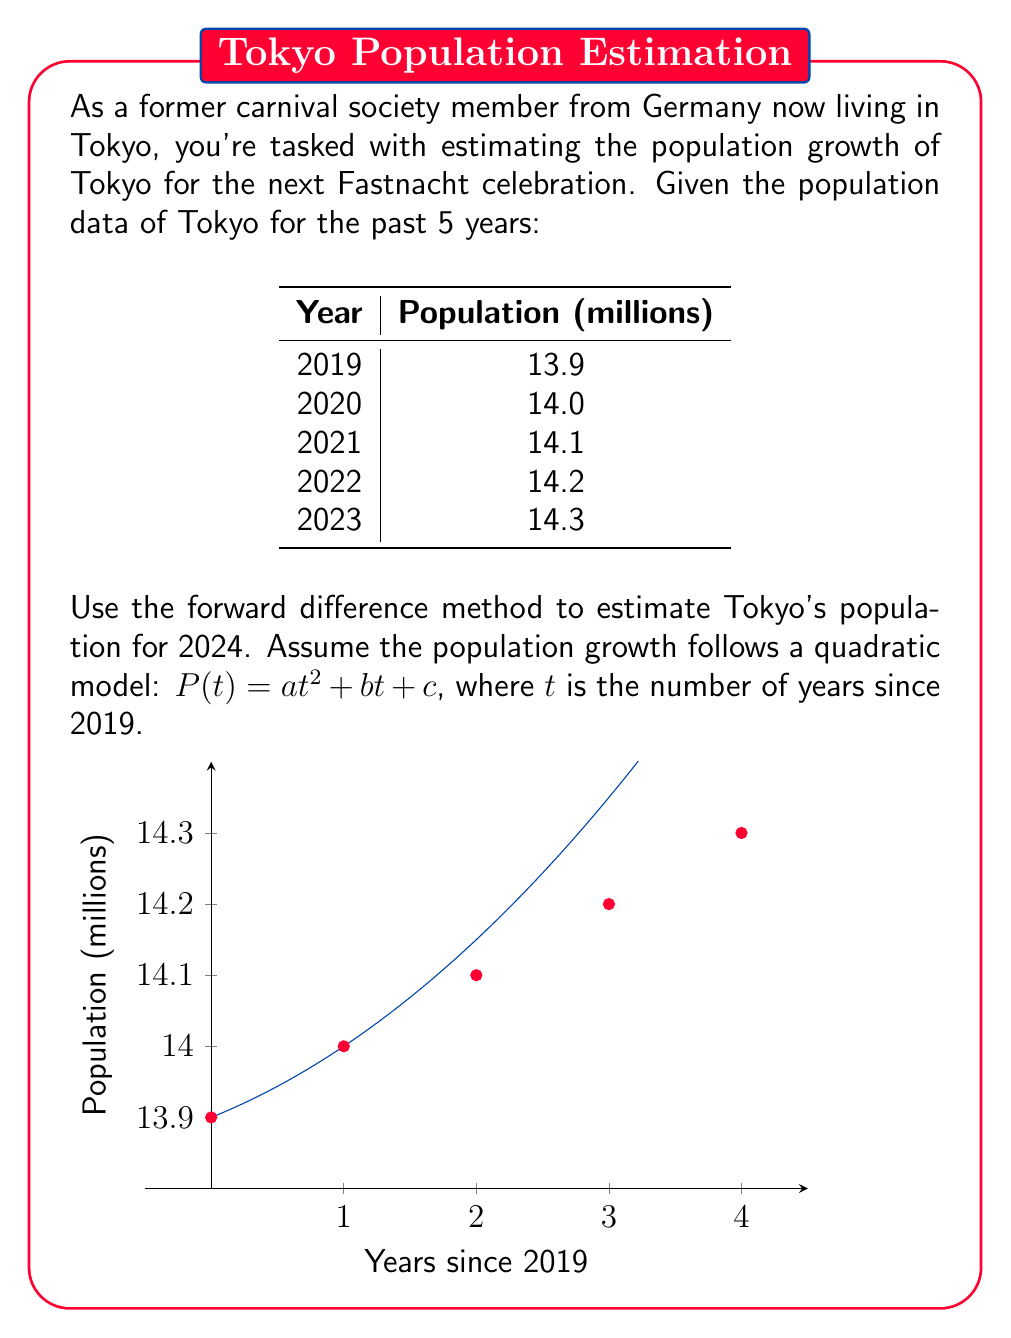Give your solution to this math problem. To solve this problem using the forward difference method, we'll follow these steps:

1) First, calculate the first-order forward differences:
   $$\Delta P_0 = P_1 - P_0 = 14.0 - 13.9 = 0.1$$
   $$\Delta P_1 = P_2 - P_1 = 14.1 - 14.0 = 0.1$$
   $$\Delta P_2 = P_3 - P_2 = 14.2 - 14.1 = 0.1$$
   $$\Delta P_3 = P_4 - P_3 = 14.3 - 14.2 = 0.1$$

2) Now, calculate the second-order forward differences:
   $$\Delta^2 P_0 = \Delta P_1 - \Delta P_0 = 0.1 - 0.1 = 0$$
   $$\Delta^2 P_1 = \Delta P_2 - \Delta P_1 = 0.1 - 0.1 = 0$$
   $$\Delta^2 P_2 = \Delta P_3 - \Delta P_2 = 0.1 - 0.1 = 0$$

3) For a quadratic model $P(t) = at^2 + bt + c$, we can use these relationships:
   $$a = \frac{\Delta^2 P_0}{2!} = 0$$
   $$b = \Delta P_0 - \frac{\Delta^2 P_0}{2} = 0.1 - 0 = 0.1$$
   $$c = P_0 = 13.9$$

4) Therefore, our quadratic model is:
   $$P(t) = 0.1t + 13.9$$

5) To estimate the population for 2024, we substitute $t = 5$ (5 years after 2019):
   $$P(5) = 0.1(5) + 13.9 = 0.5 + 13.9 = 14.4$$

Thus, the estimated population of Tokyo for 2024 is 14.4 million.
Answer: 14.4 million 